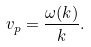<formula> <loc_0><loc_0><loc_500><loc_500>v _ { p } = { \frac { \omega ( k ) } { k } } .</formula> 